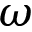Convert formula to latex. <formula><loc_0><loc_0><loc_500><loc_500>\omega</formula> 